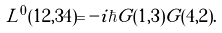Convert formula to latex. <formula><loc_0><loc_0><loc_500><loc_500>L ^ { 0 } ( 1 2 , 3 4 ) = - i \hbar { G } ( 1 , 3 ) G ( 4 , 2 ) .</formula> 